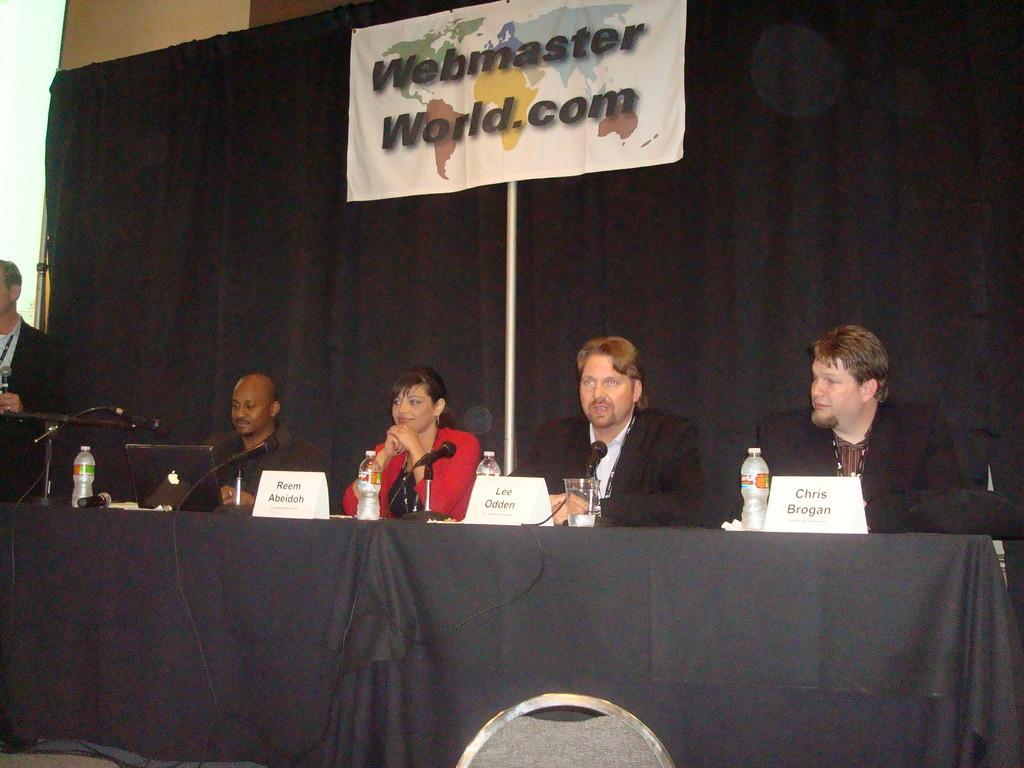Describe this image in one or two sentences. In this image we can see four people sitting on the chairs near the table, one table with black tablecloth, one screen on the left side of the image, one chair near the table, one pole, one big black curtain attached to the wall, one banner with text and image attached to the pole. There is one laptop on the table, some water bottles, some name boards, some microphones with wires and stands on the table. There are some objects on the table, one object near to the table, one man standing and holding a microphone. 